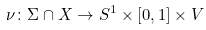<formula> <loc_0><loc_0><loc_500><loc_500>\nu \colon \Sigma \cap X \to S ^ { 1 } \times [ 0 , 1 ] \times V</formula> 